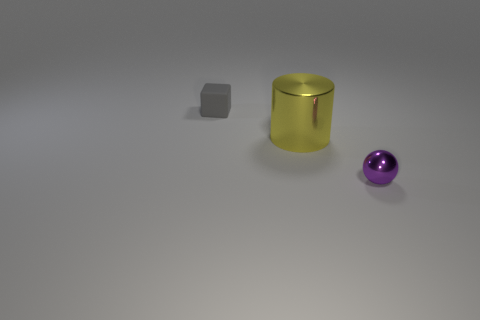Subtract all cylinders. How many objects are left? 2 Add 2 yellow blocks. How many objects exist? 5 Subtract all cyan cylinders. How many purple cubes are left? 0 Subtract all metallic cylinders. Subtract all small purple shiny things. How many objects are left? 1 Add 1 yellow cylinders. How many yellow cylinders are left? 2 Add 1 tiny spheres. How many tiny spheres exist? 2 Subtract 0 purple blocks. How many objects are left? 3 Subtract 1 cylinders. How many cylinders are left? 0 